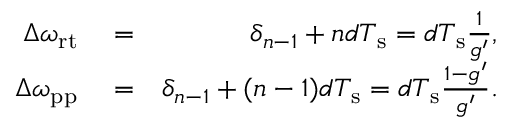Convert formula to latex. <formula><loc_0><loc_0><loc_500><loc_500>\begin{array} { r l r } { \Delta \omega _ { r t } } & = } & { \delta _ { n - 1 } + n d T _ { s } = d T _ { s } \frac { 1 } { g ^ { \prime } } , } \\ { \Delta \omega _ { p p } } & = } & { \delta _ { n - 1 } + ( n - 1 ) d T _ { s } = d T _ { s } \frac { 1 - g ^ { \prime } } { g ^ { \prime } } . } \end{array}</formula> 